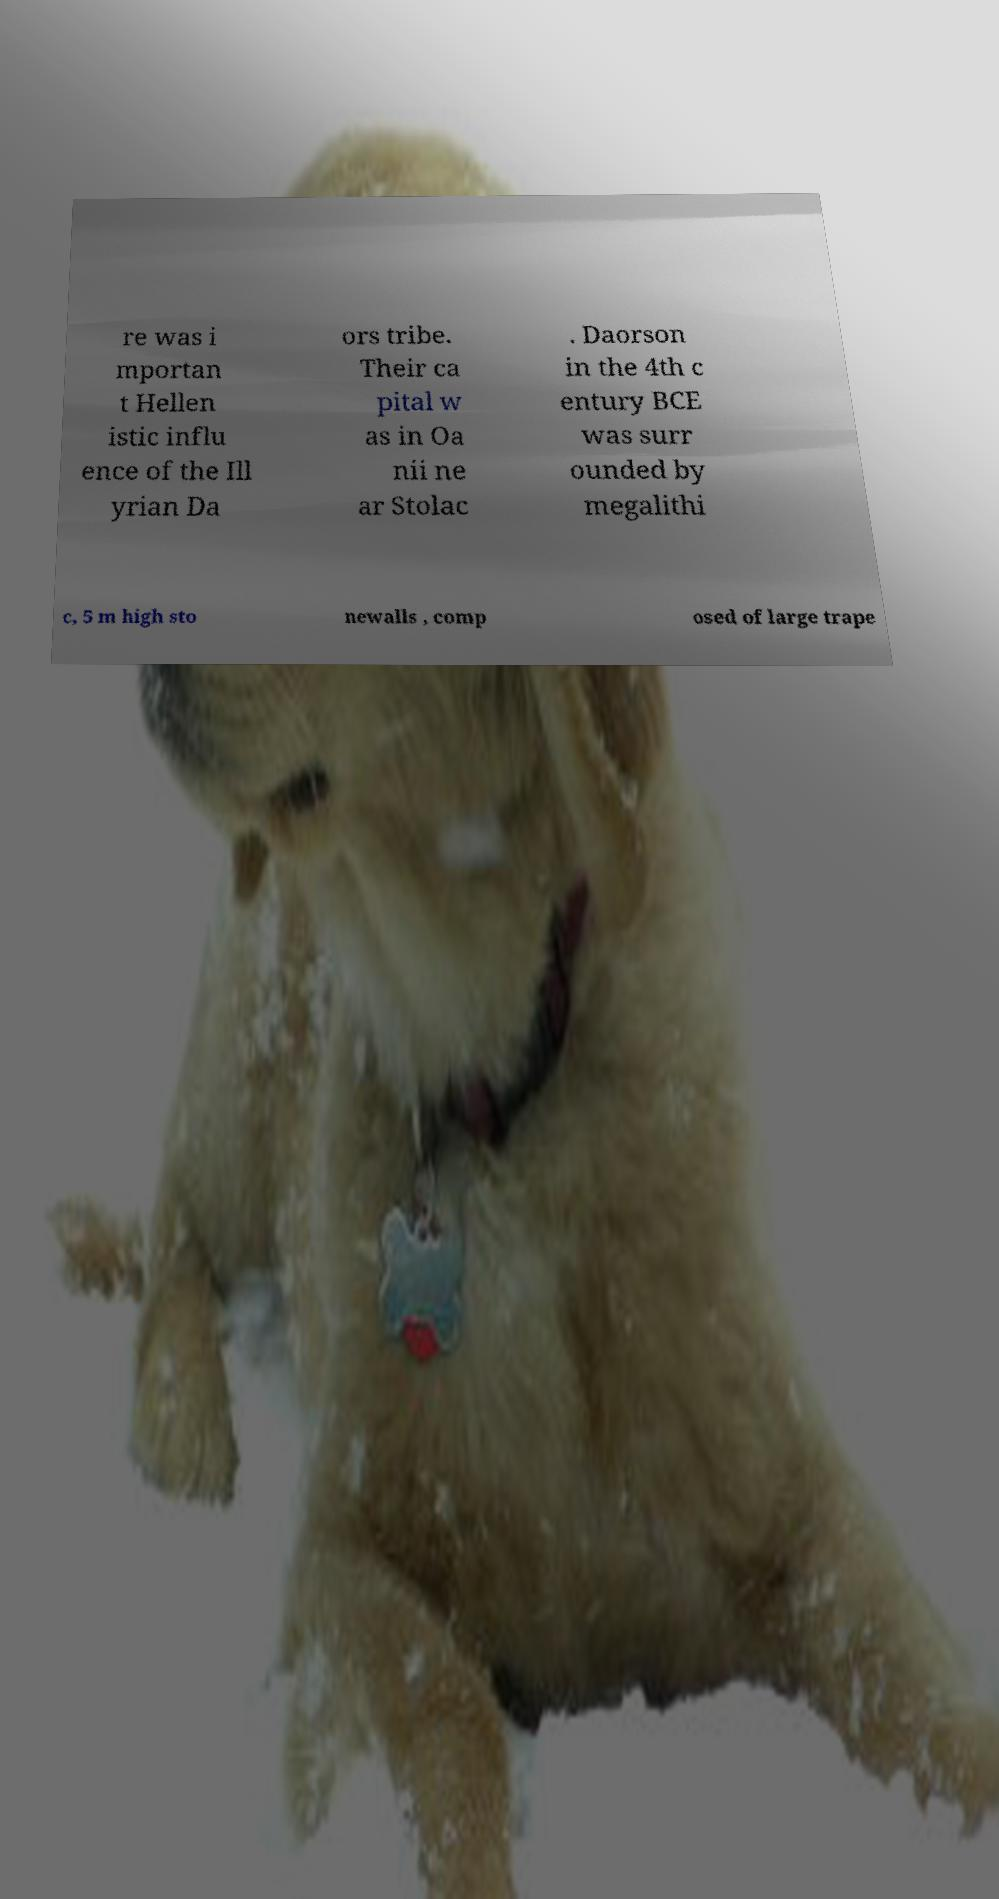There's text embedded in this image that I need extracted. Can you transcribe it verbatim? re was i mportan t Hellen istic influ ence of the Ill yrian Da ors tribe. Their ca pital w as in Oa nii ne ar Stolac . Daorson in the 4th c entury BCE was surr ounded by megalithi c, 5 m high sto newalls , comp osed of large trape 